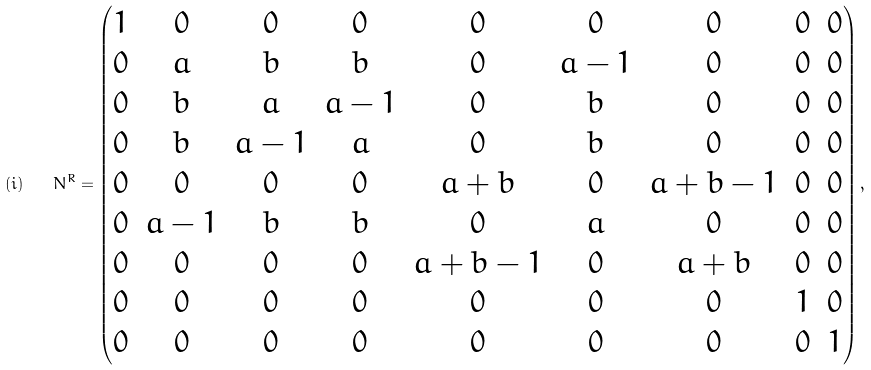Convert formula to latex. <formula><loc_0><loc_0><loc_500><loc_500>( i ) \quad N ^ { R } = \begin{pmatrix} 1 & 0 & 0 & 0 & 0 & 0 & 0 & 0 & 0 \\ 0 & a & b & b & 0 & a - 1 & 0 & 0 & 0 \\ 0 & b & a & a - 1 & 0 & b & 0 & 0 & 0 \\ 0 & b & a - 1 & a & 0 & b & 0 & 0 & 0 \\ 0 & 0 & 0 & 0 & a + b & 0 & a + b - 1 & 0 & 0 \\ 0 & a - 1 & b & b & 0 & a & 0 & 0 & 0 \\ 0 & 0 & 0 & 0 & a + b - 1 & 0 & a + b & 0 & 0 \\ 0 & 0 & 0 & 0 & 0 & 0 & 0 & 1 & 0 \\ 0 & 0 & 0 & 0 & 0 & 0 & 0 & 0 & 1 \end{pmatrix} ,</formula> 